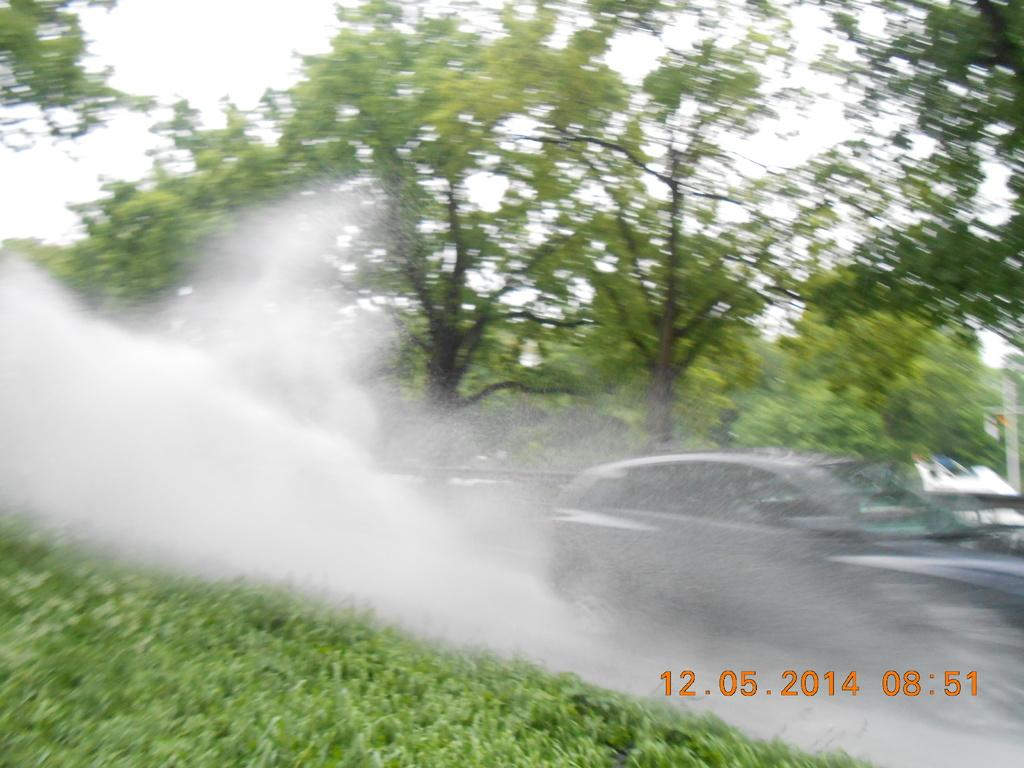What type of natural environment is visible in the image? There is grass and water visible in the image. What man-made object can be seen in the image? There is a car in the image. What type of vegetation is in the background of the image? There are trees in the background of the image. Is there any indication of when the image was taken? Yes, there is a timestamp is present in the bottom right hand corner of the image. What type of teaching is being offered in the image? There is no teaching or offer present in the image; it features grass, water, a car, trees, and a timestamp. 